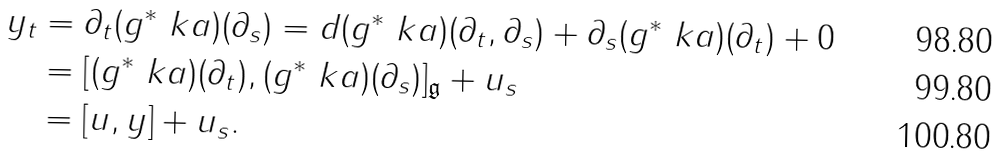<formula> <loc_0><loc_0><loc_500><loc_500>y _ { t } & = \partial _ { t } ( g ^ { * } \ k a ) ( \partial _ { s } ) = d ( g ^ { * } \ k a ) ( \partial _ { t } , \partial _ { s } ) + \partial _ { s } ( g ^ { * } \ k a ) ( \partial _ { t } ) + 0 \\ & = [ ( g ^ { * } \ k a ) ( \partial _ { t } ) , ( g ^ { * } \ k a ) ( \partial _ { s } ) ] _ { \mathfrak g } + u _ { s } \\ & = [ u , y ] + u _ { s } .</formula> 